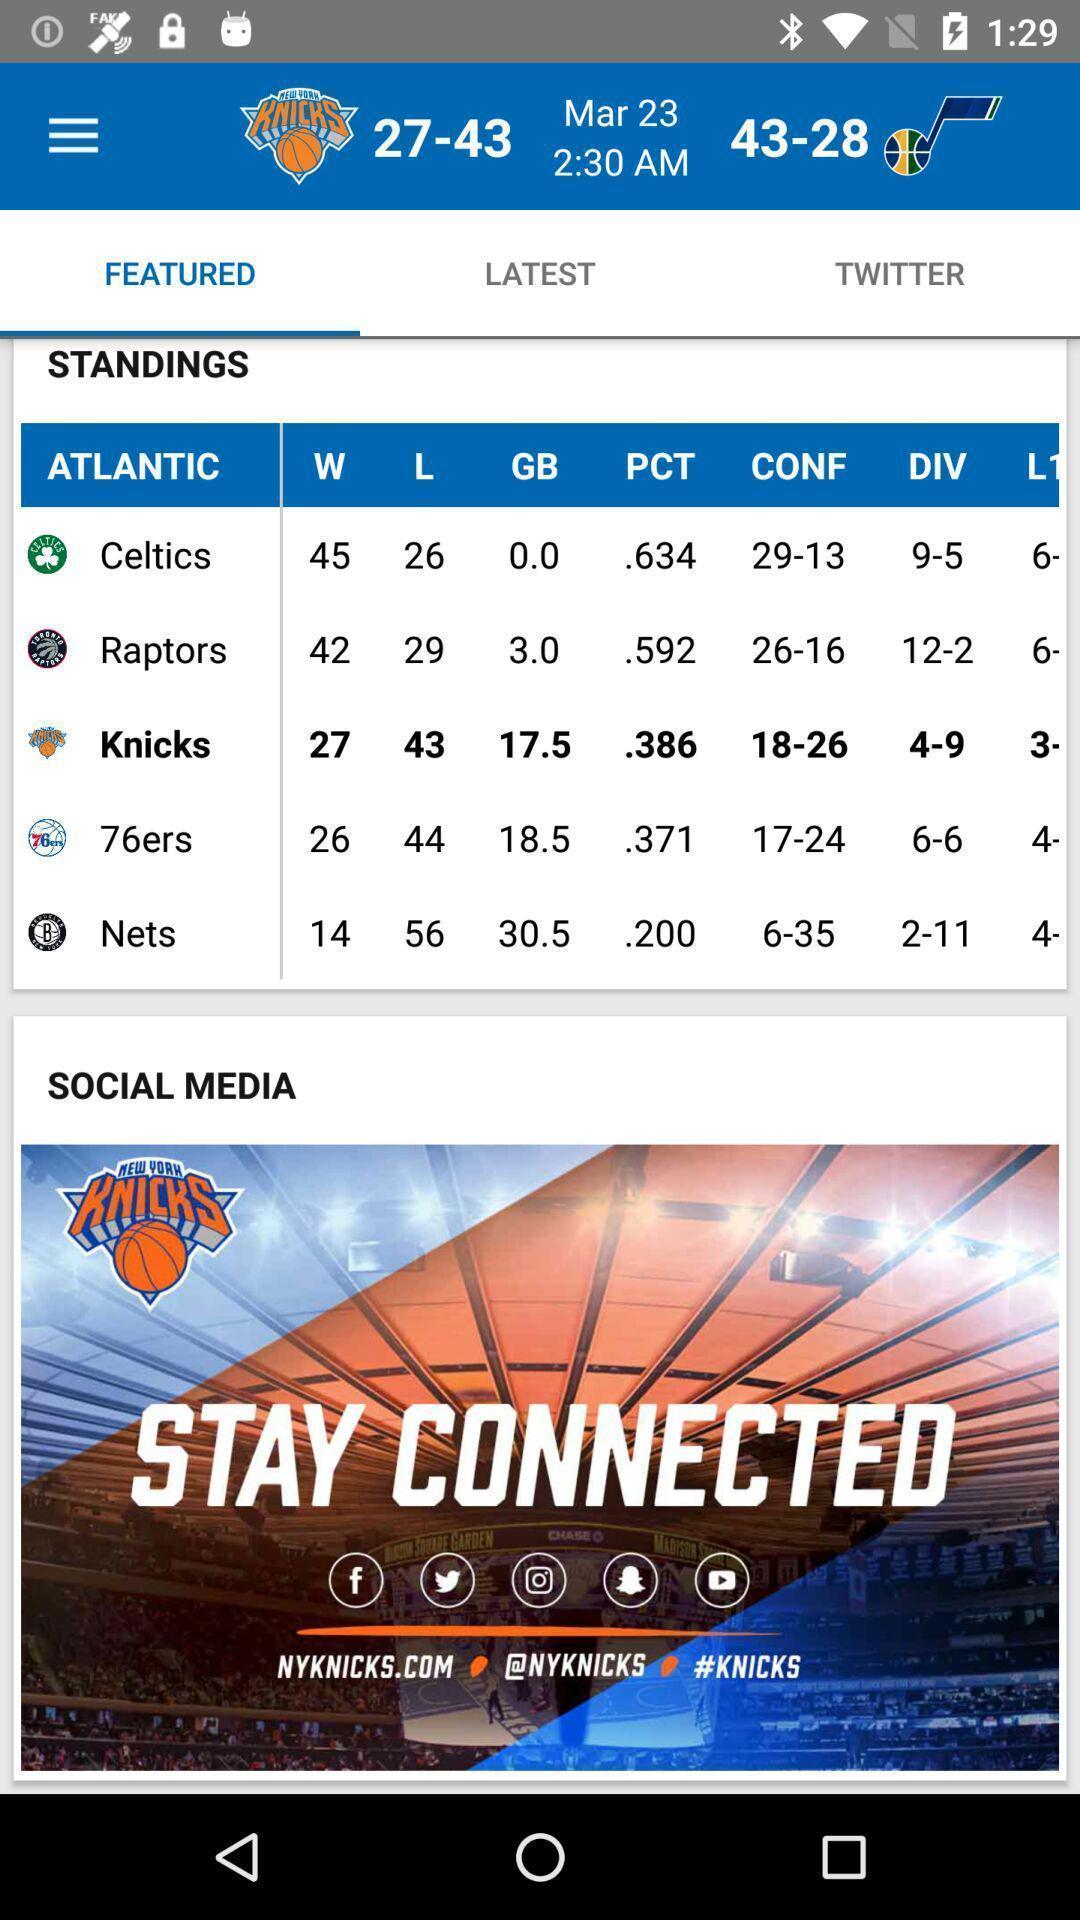Summarize the main components in this picture. Screen showing featured in an sports application. 